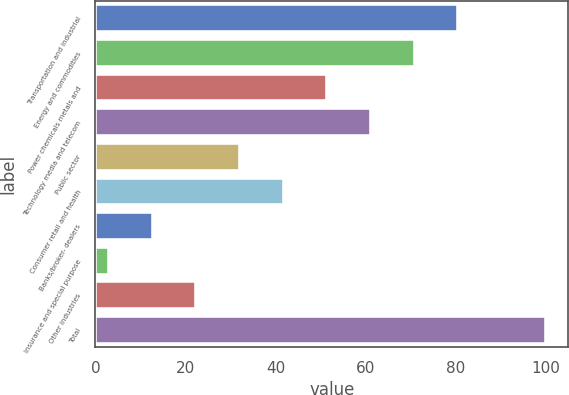Convert chart to OTSL. <chart><loc_0><loc_0><loc_500><loc_500><bar_chart><fcel>Transportation and industrial<fcel>Energy and commodities<fcel>Power chemicals metals and<fcel>Technology media and telecom<fcel>Public sector<fcel>Consumer retail and health<fcel>Banks/broker- dealers<fcel>Insurance and special purpose<fcel>Other industries<fcel>Total<nl><fcel>80.6<fcel>70.9<fcel>51.5<fcel>61.2<fcel>32.1<fcel>41.8<fcel>12.7<fcel>3<fcel>22.4<fcel>100<nl></chart> 